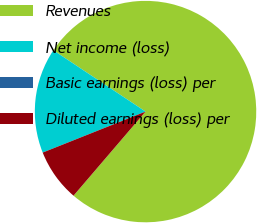<chart> <loc_0><loc_0><loc_500><loc_500><pie_chart><fcel>Revenues<fcel>Net income (loss)<fcel>Basic earnings (loss) per<fcel>Diluted earnings (loss) per<nl><fcel>76.92%<fcel>15.38%<fcel>0.0%<fcel>7.69%<nl></chart> 